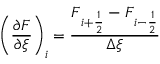<formula> <loc_0><loc_0><loc_500><loc_500>\left ( \frac { \partial F } { \partial \xi } \right ) _ { i } = \frac { F _ { i + \frac { 1 } { 2 } } - F _ { i - \frac { 1 } { 2 } } } { \Delta \xi }</formula> 